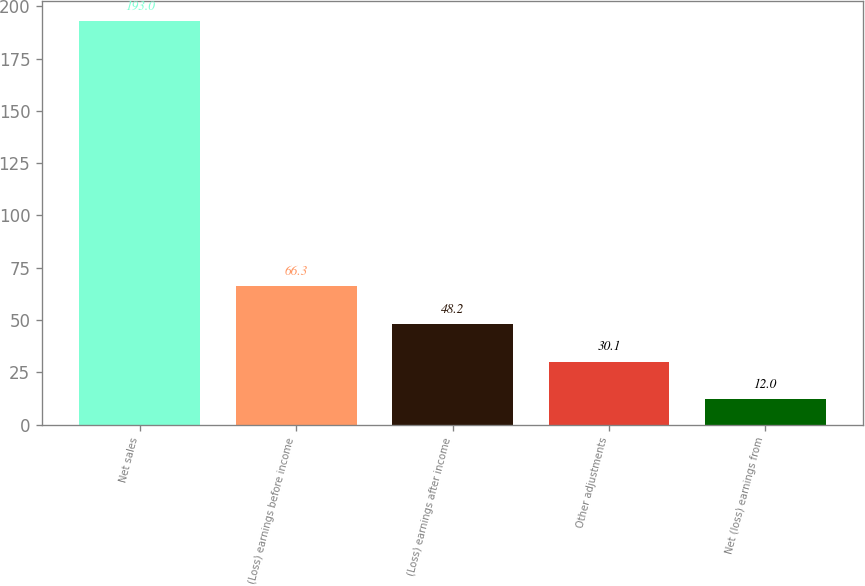<chart> <loc_0><loc_0><loc_500><loc_500><bar_chart><fcel>Net sales<fcel>(Loss) earnings before income<fcel>(Loss) earnings after income<fcel>Other adjustments<fcel>Net (loss) earnings from<nl><fcel>193<fcel>66.3<fcel>48.2<fcel>30.1<fcel>12<nl></chart> 